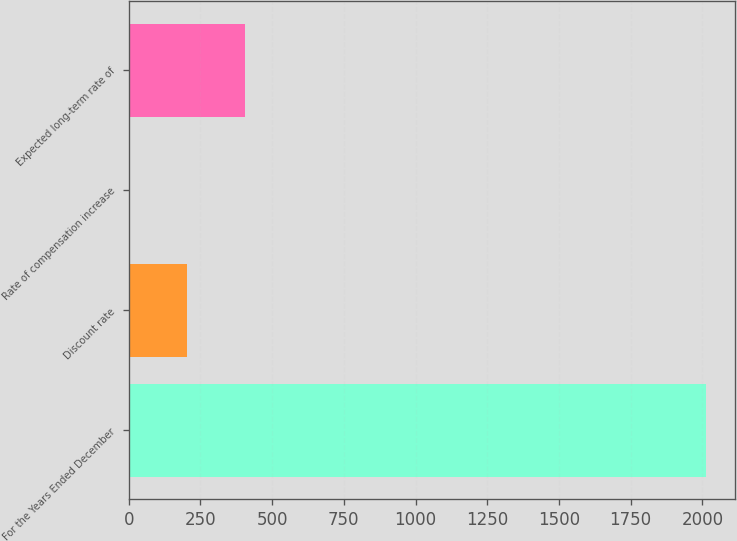Convert chart. <chart><loc_0><loc_0><loc_500><loc_500><bar_chart><fcel>For the Years Ended December<fcel>Discount rate<fcel>Rate of compensation increase<fcel>Expected long-term rate of<nl><fcel>2012<fcel>204.63<fcel>3.81<fcel>405.45<nl></chart> 